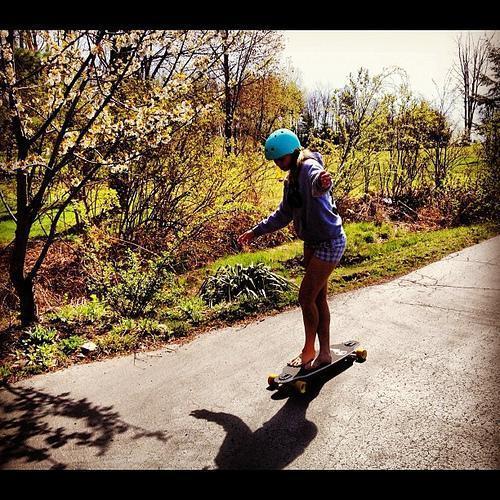How many people are there?
Give a very brief answer. 1. 